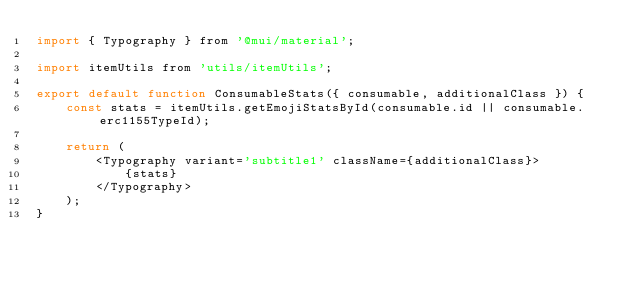Convert code to text. <code><loc_0><loc_0><loc_500><loc_500><_JavaScript_>import { Typography } from '@mui/material';

import itemUtils from 'utils/itemUtils';

export default function ConsumableStats({ consumable, additionalClass }) {
    const stats = itemUtils.getEmojiStatsById(consumable.id || consumable.erc1155TypeId);

    return (
        <Typography variant='subtitle1' className={additionalClass}>
            {stats}
        </Typography>
    );
}
</code> 